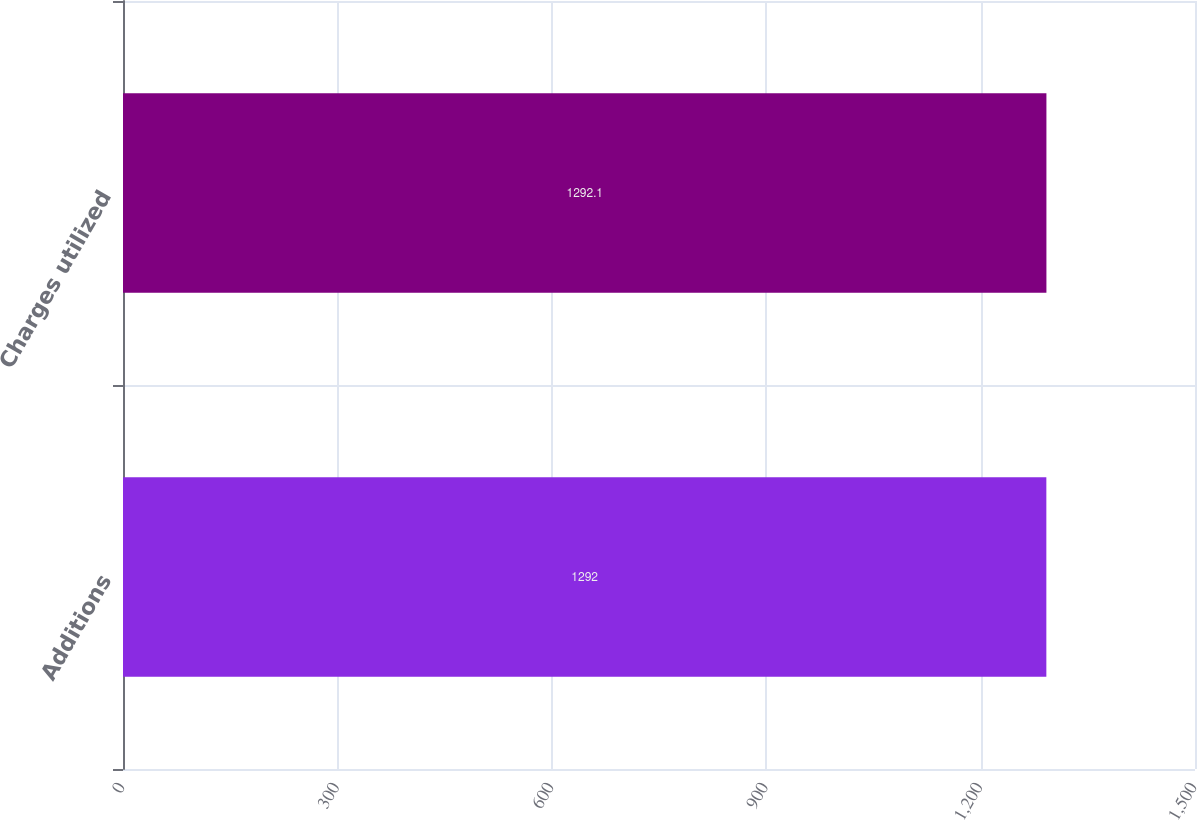Convert chart. <chart><loc_0><loc_0><loc_500><loc_500><bar_chart><fcel>Additions<fcel>Charges utilized<nl><fcel>1292<fcel>1292.1<nl></chart> 